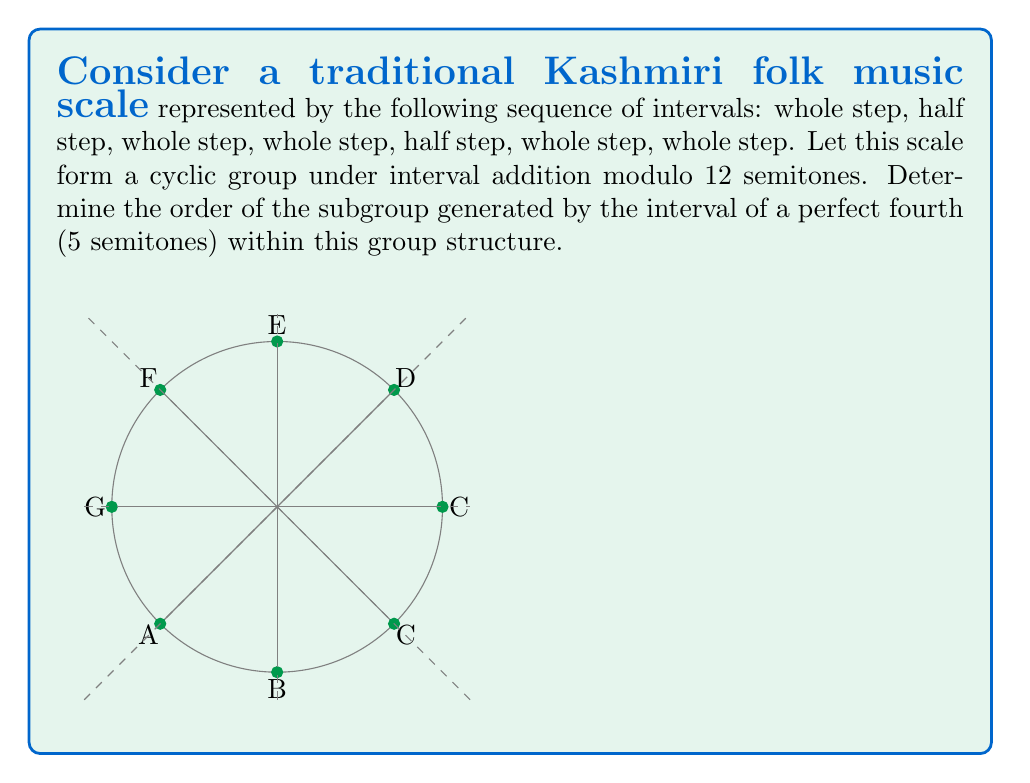Could you help me with this problem? Let's approach this step-by-step:

1) First, we need to understand the group structure. The scale forms a cyclic group of order 12 under interval addition modulo 12 semitones. We can denote this group as $\mathbb{Z}_{12}$.

2) We are asked to find the order of the subgroup generated by the perfect fourth (5 semitones). In group theory terms, we need to find the order of the element 5 in $\mathbb{Z}_{12}$.

3) To find the order, we need to determine the smallest positive integer $n$ such that:

   $5n \equiv 0 \pmod{12}$

4) Let's compute the multiples of 5 modulo 12:
   
   $5 \cdot 1 \equiv 5 \pmod{12}$
   $5 \cdot 2 \equiv 10 \pmod{12}$
   $5 \cdot 3 \equiv 3 \pmod{12}$
   $5 \cdot 4 \equiv 8 \pmod{12}$
   $5 \cdot 5 \equiv 1 \pmod{12}$
   $5 \cdot 6 \equiv 6 \pmod{12}$
   $5 \cdot 7 \equiv 11 \pmod{12}$
   $5 \cdot 8 \equiv 4 \pmod{12}$
   $5 \cdot 9 \equiv 9 \pmod{12}$
   $5 \cdot 10 \equiv 2 \pmod{12}$
   $5 \cdot 11 \equiv 7 \pmod{12}$
   $5 \cdot 12 \equiv 0 \pmod{12}$

5) We see that the smallest positive integer $n$ for which $5n \equiv 0 \pmod{12}$ is 12.

6) Therefore, the order of the subgroup generated by the perfect fourth (5 semitones) is 12.

This result implies that the perfect fourth generates the entire group, making it a generator of the Kashmiri folk music scale under this algebraic structure.
Answer: 12 